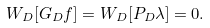Convert formula to latex. <formula><loc_0><loc_0><loc_500><loc_500>W _ { D } [ G _ { D } f ] = W _ { D } [ P _ { D } \lambda ] = 0 .</formula> 